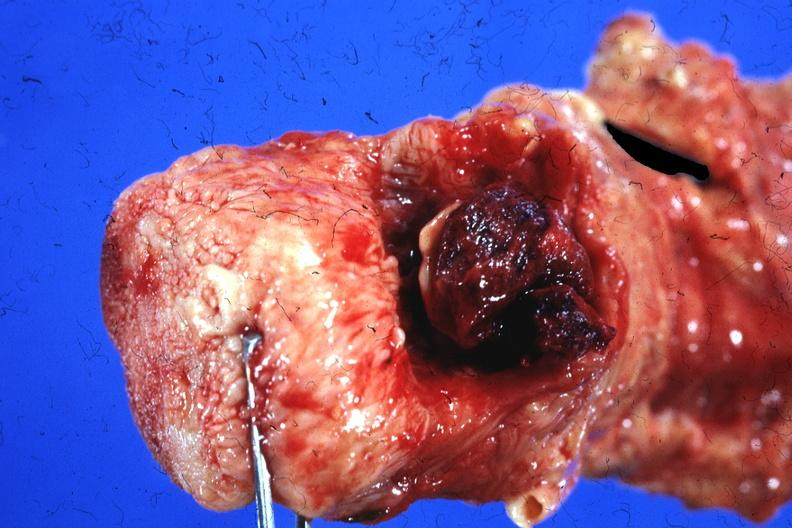what does this image show?
Answer the question using a single word or phrase. Tongue and unopened larynx with blood clot over larynx chronic myeloproliferative disease with acute trans-formation and bleeding disorder 